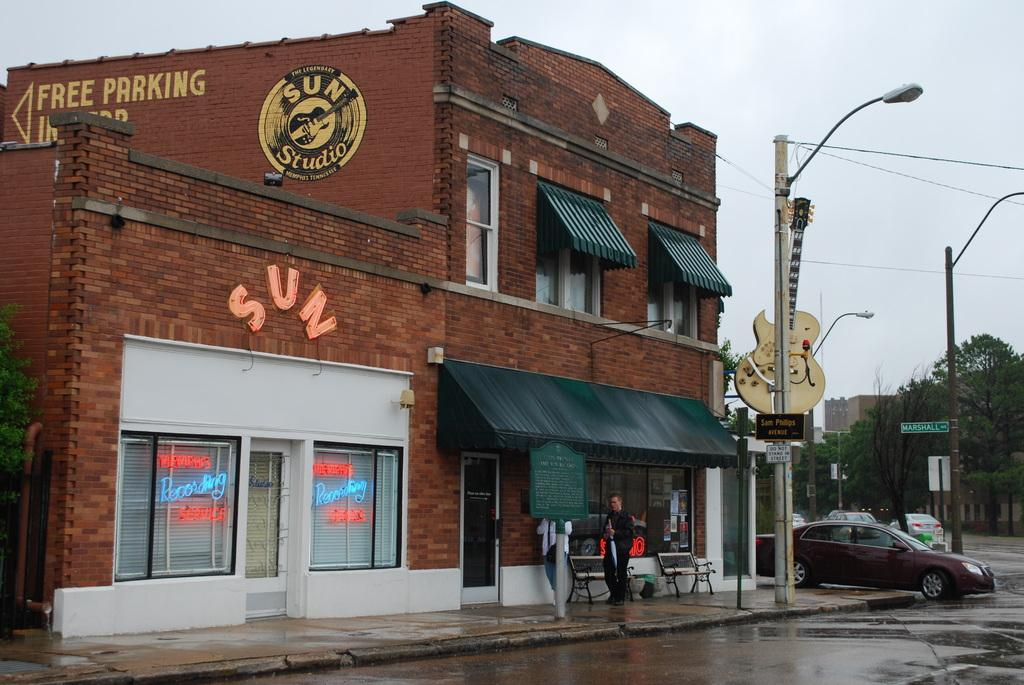<image>
Relay a brief, clear account of the picture shown. Sun Studio's building with Free Parking behind it. 